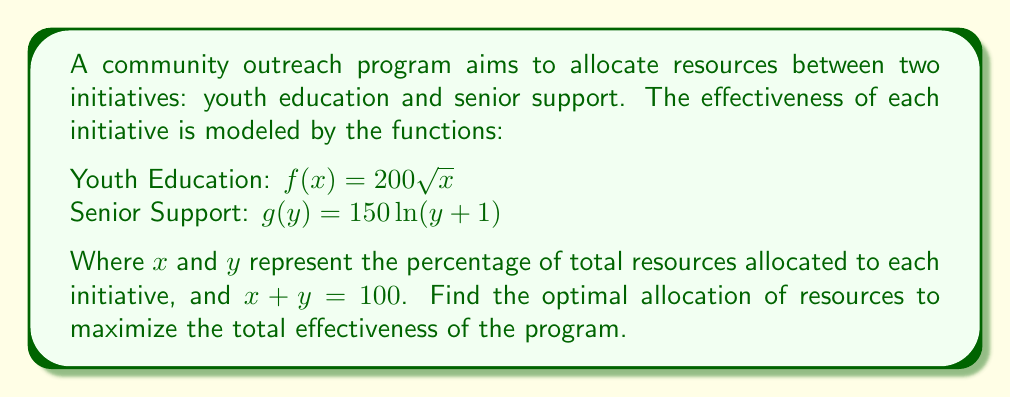Can you solve this math problem? 1) Let's define the total effectiveness function:
   $E(x) = f(x) + g(100-x) = 200\sqrt{x} + 150\ln(101-x)$

2) To find the maximum, we need to find where $\frac{dE}{dx} = 0$:
   $$\frac{dE}{dx} = \frac{100}{\sqrt{x}} - \frac{150}{101-x} = 0$$

3) Solving this equation:
   $$\frac{100}{\sqrt{x}} = \frac{150}{101-x}$$
   $$(101-x)\cdot 100 = 150\sqrt{x}$$
   $$10100 - 100x = 150\sqrt{x}$$

4) Square both sides:
   $$(10100 - 100x)^2 = 22500x$$
   $$102010000 - 2020000x + 10000x^2 = 22500x$$
   $$10000x^2 - 2042500x + 102010000 = 0$$

5) This is a quadratic equation. Solve using the quadratic formula:
   $$x = \frac{2042500 \pm \sqrt{2042500^2 - 4\cdot10000\cdot102010000}}{2\cdot10000}$$

6) Simplifying:
   $$x \approx 64.04\% \text{ or } 140.21\%$$

7) Since x represents a percentage, we choose the feasible solution: 64.04%

8) Therefore, y = 100% - 64.04% = 35.96%
Answer: Youth Education: 64.04%, Senior Support: 35.96% 